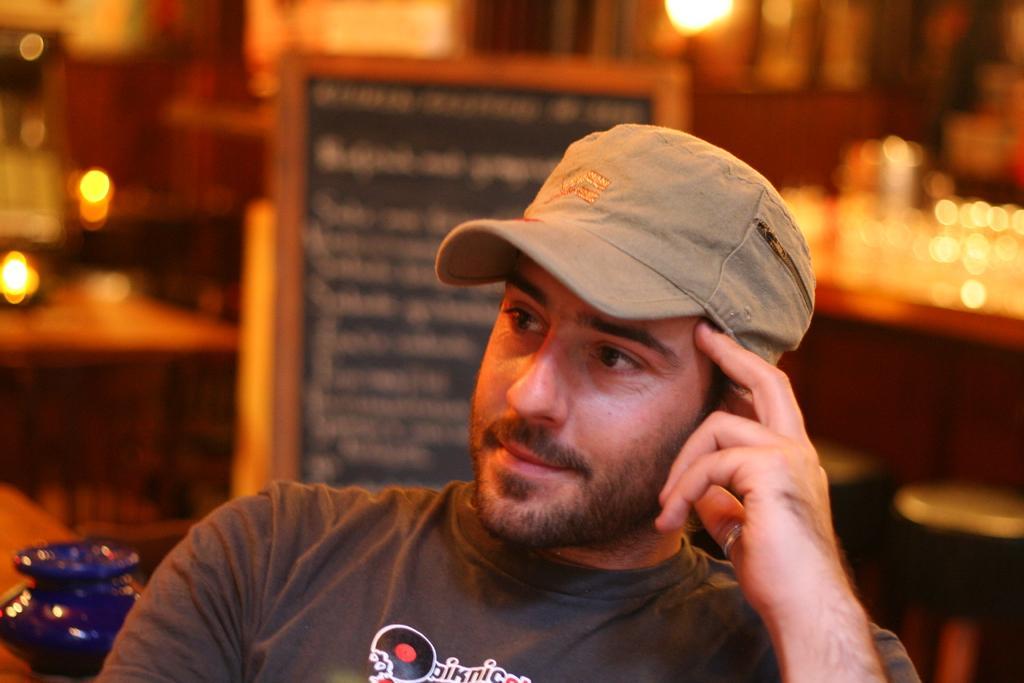How would you summarize this image in a sentence or two? In this image there is a person, behind the person there is a display board. 